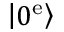Convert formula to latex. <formula><loc_0><loc_0><loc_500><loc_500>\left | 0 ^ { e } \right \rangle</formula> 